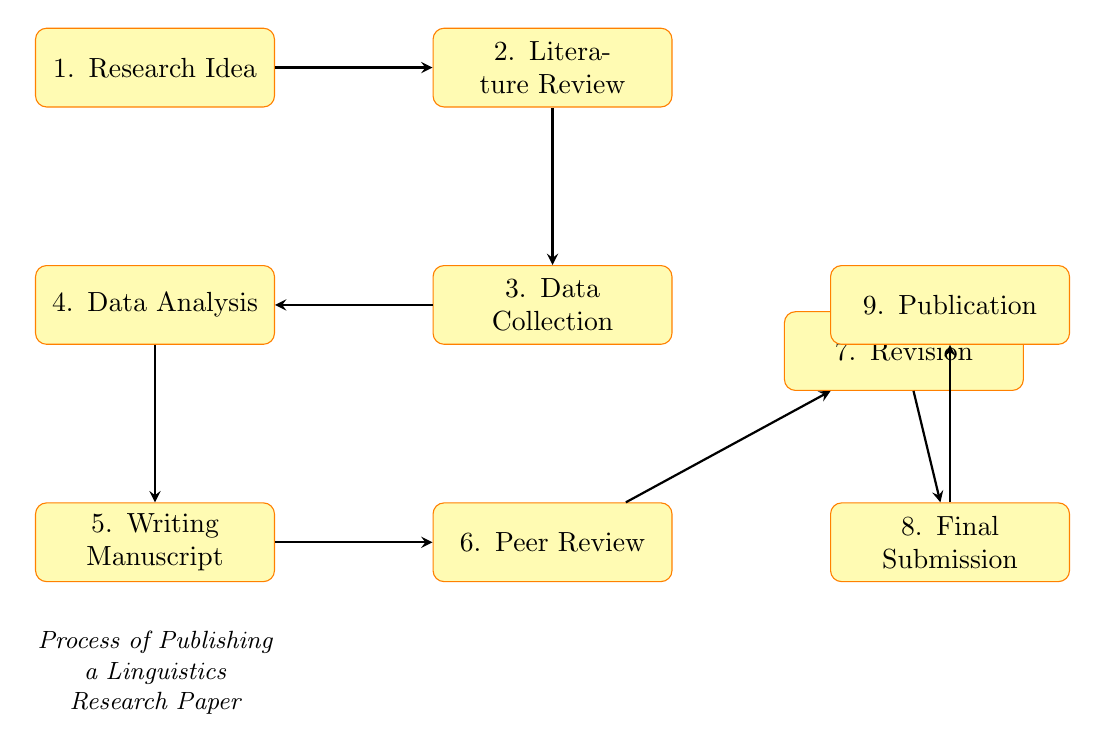What is the first stage in the process? The diagram begins with the node labeled "1. Research Idea." This node represents the initiation of the process, making it the first stage.
Answer: Research Idea How many stages are there in total? The diagram contains nine distinct stages, each represented by its respective node from the "Research Idea" to "Publication."
Answer: 9 What is the last step of the process? According to the diagram, the final step is labeled "9. Publication," indicating the completion of the publishing process.
Answer: Publication Which stage comes immediately after "Data Analysis"? The flow chart shows that "5. Writing Manuscript" directly follows "4. Data Analysis," indicating the next task in the sequence.
Answer: Writing Manuscript What does the stage "Peer Review" lead to? Based on the flow of arrows in the diagram, "Peer Review" (stage 6) leads to "Revision," which is stage 7. This connection indicates the progression from review to revision.
Answer: Revision Which two stages are connected by the same arrow in the flow? The arrow connecting "Write Manuscript" and "Peer Review" shows a direct link where the output of writing leads into the peer review stage. This illustrates the sequential relationship between these two specific stages.
Answer: Writing Manuscript and Peer Review How is the relationship between the stages "Revision" and "Final Submission"? In the diagram, "Revision" (stage 7) leads to "Final Submission" (stage 8), indicating that after revision, the manuscript is submitted for final acceptance. This relationship clarifies the workflow's order and necessity of revising before final submission.
Answer: Revision and Final Submission What comes after "Data Collection"? From the flow chart, "Data Collection" is followed by "Data Analysis," indicating that data collected must be analyzed next in the research process.
Answer: Data Analysis Which two stages directly involve written output? The stages "Writing Manuscript" and "Final Submission" both require the creation of written documents; first, a manuscript is written and then finalized for submission to a journal. This indicates the importance of writing in the research publication process.
Answer: Writing Manuscript and Final Submission 